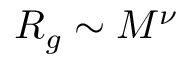<formula> <loc_0><loc_0><loc_500><loc_500>R _ { g } \sim M ^ { \nu }</formula> 